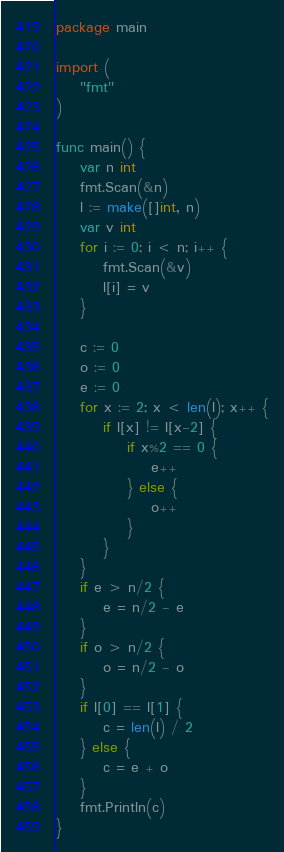Convert code to text. <code><loc_0><loc_0><loc_500><loc_500><_Go_>package main

import (
	"fmt"
)

func main() {
	var n int
	fmt.Scan(&n)
	l := make([]int, n)
	var v int
	for i := 0; i < n; i++ {
		fmt.Scan(&v)
		l[i] = v
	}

	c := 0
	o := 0
	e := 0
	for x := 2; x < len(l); x++ {
		if l[x] != l[x-2] {
			if x%2 == 0 {
				e++
			} else {
				o++
			}
		}
	}
	if e > n/2 {
		e = n/2 - e
	}
	if o > n/2 {
		o = n/2 - o
	}
	if l[0] == l[1] {
		c = len(l) / 2
	} else {
		c = e + o
	}
	fmt.Println(c)
}
</code> 